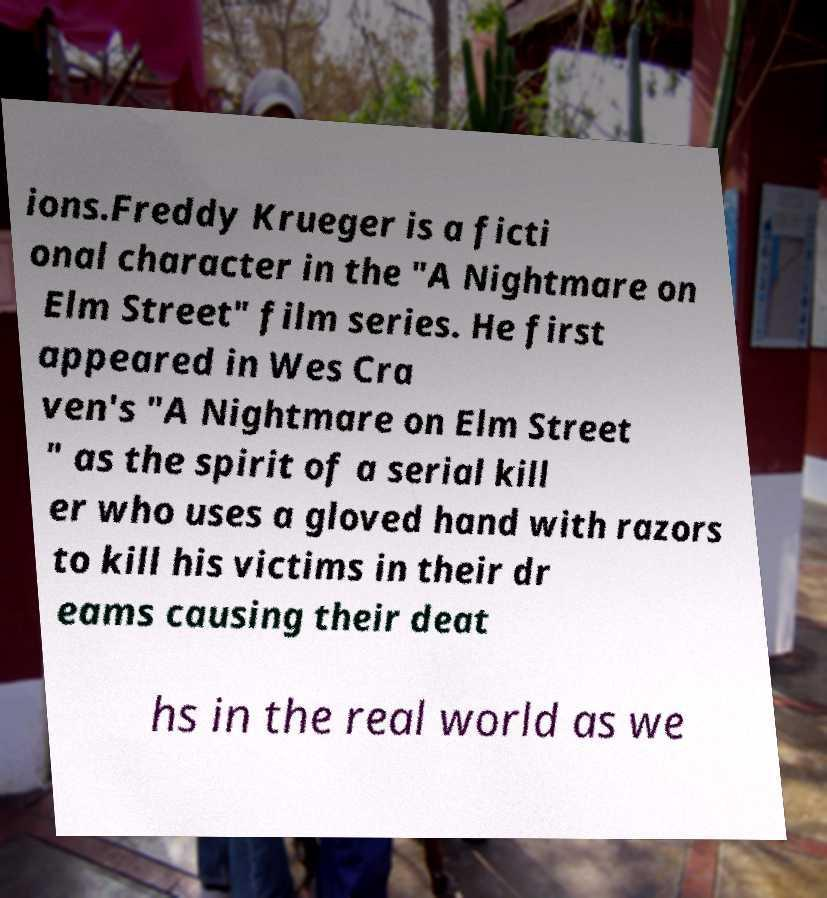Could you assist in decoding the text presented in this image and type it out clearly? ions.Freddy Krueger is a ficti onal character in the "A Nightmare on Elm Street" film series. He first appeared in Wes Cra ven's "A Nightmare on Elm Street " as the spirit of a serial kill er who uses a gloved hand with razors to kill his victims in their dr eams causing their deat hs in the real world as we 